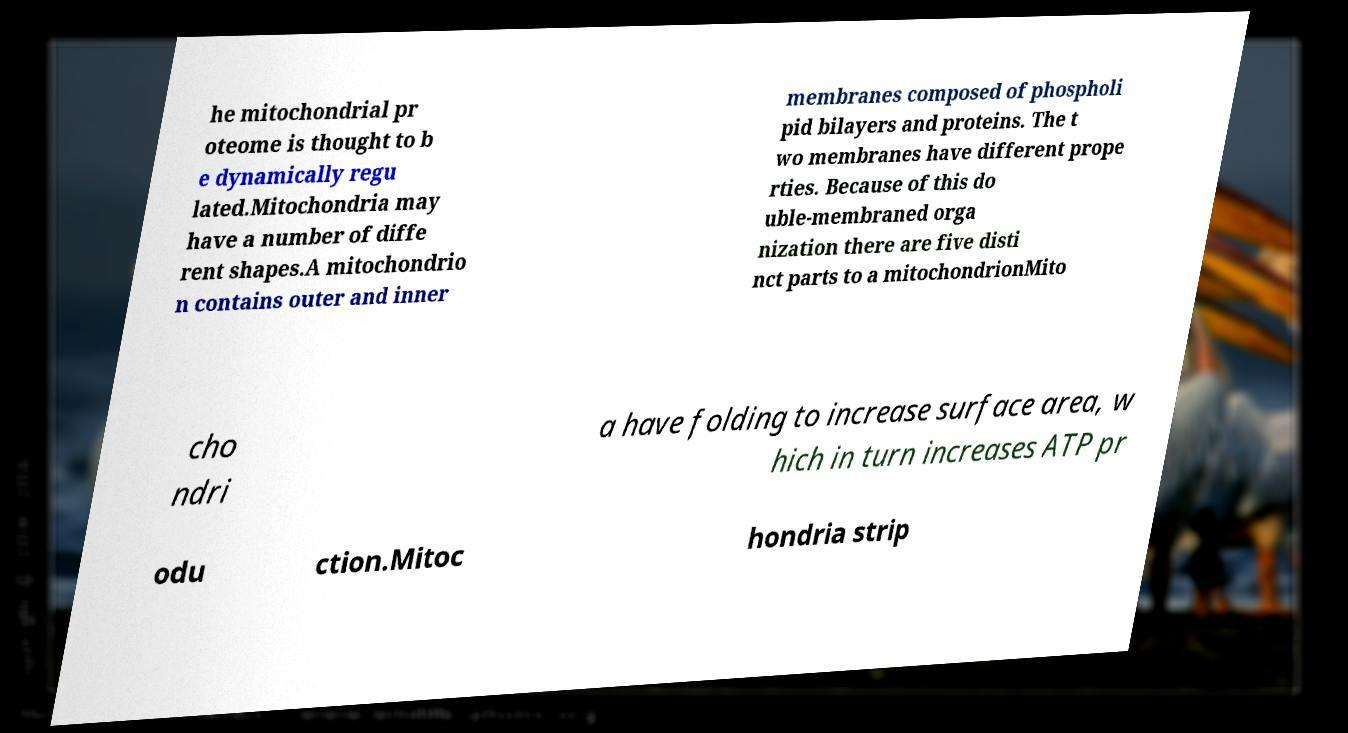There's text embedded in this image that I need extracted. Can you transcribe it verbatim? he mitochondrial pr oteome is thought to b e dynamically regu lated.Mitochondria may have a number of diffe rent shapes.A mitochondrio n contains outer and inner membranes composed of phospholi pid bilayers and proteins. The t wo membranes have different prope rties. Because of this do uble-membraned orga nization there are five disti nct parts to a mitochondrionMito cho ndri a have folding to increase surface area, w hich in turn increases ATP pr odu ction.Mitoc hondria strip 